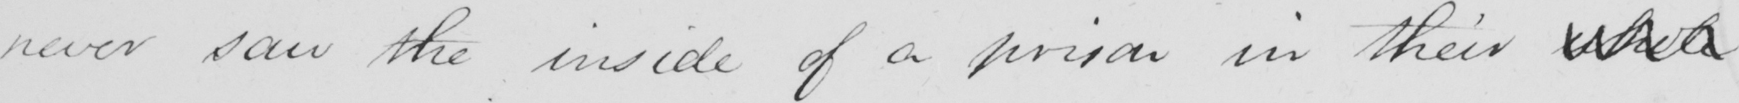Can you tell me what this handwritten text says? never saw the inside of a prison in their whole 